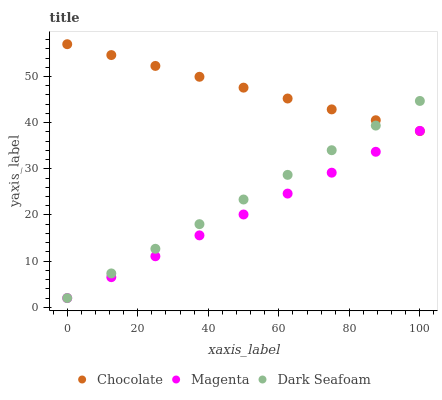Does Magenta have the minimum area under the curve?
Answer yes or no. Yes. Does Chocolate have the maximum area under the curve?
Answer yes or no. Yes. Does Dark Seafoam have the minimum area under the curve?
Answer yes or no. No. Does Dark Seafoam have the maximum area under the curve?
Answer yes or no. No. Is Magenta the smoothest?
Answer yes or no. Yes. Is Chocolate the roughest?
Answer yes or no. Yes. Is Dark Seafoam the smoothest?
Answer yes or no. No. Is Dark Seafoam the roughest?
Answer yes or no. No. Does Magenta have the lowest value?
Answer yes or no. Yes. Does Chocolate have the lowest value?
Answer yes or no. No. Does Chocolate have the highest value?
Answer yes or no. Yes. Does Dark Seafoam have the highest value?
Answer yes or no. No. Does Chocolate intersect Magenta?
Answer yes or no. Yes. Is Chocolate less than Magenta?
Answer yes or no. No. Is Chocolate greater than Magenta?
Answer yes or no. No. 